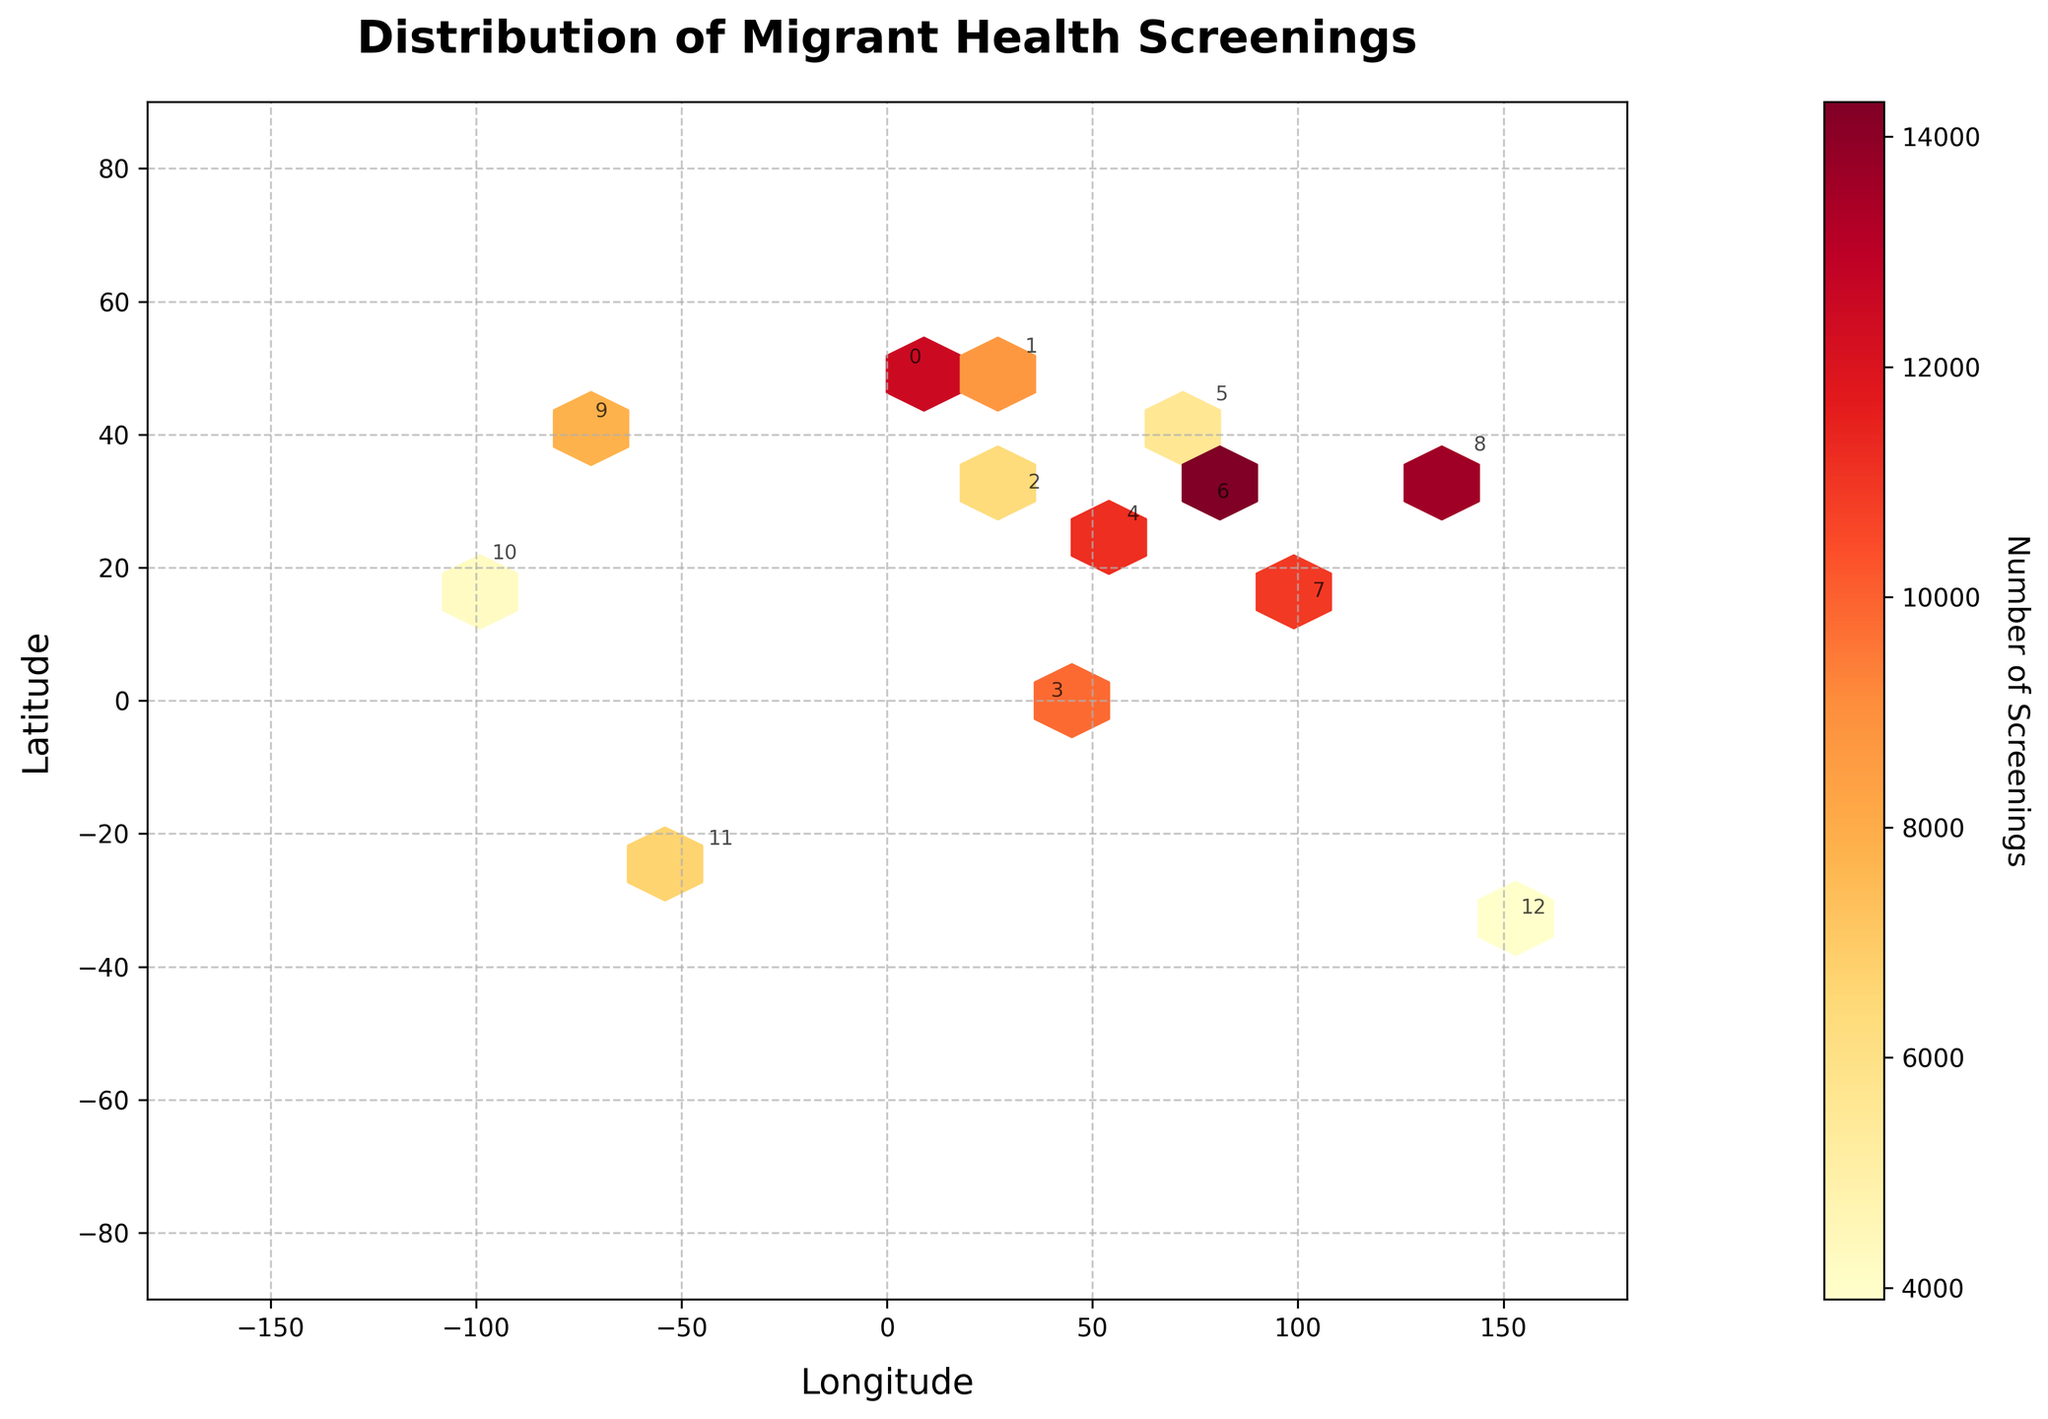What is the title of the hexbin plot? The title of the hexbin plot is usually found at the top of the figure. In this case, it reads "Distribution of Migrant Health Screenings".
Answer: Distribution of Migrant Health Screenings Which global region appears to have the highest number of screenings? The region with the highest number of screenings will have the most saturated color (yellow/red) in the hex bin plot near its geographic coordinates. South Asia has the highest screenings at approximately 14300.
Answer: South Asia What does the color gradient indicate in the hexbin plot? In hexbin plots, the color gradient typically represents the numerical magnitude of the values being plotted. Here, it reflects the number of health screenings, with lighter colors indicating higher numbers.
Answer: Number of Screenings Which two regions are geographically closest to each other? To determine this, you need to look at the relative positions of the annotations on the plot, considering their latitudes and longitudes. Western Europe and Eastern Europe are geographically closest based on their longitude and latitude values.
Answer: Western Europe and Eastern Europe Which region has the lowest number of health screenings, and what is that number? The color representing the least saturated part of the hexbin plot signifies the region with the lowest health screenings. Oceania, around -33.8688 latitude and 151.2093 longitude, has the lowest with 3900 screenings.
Answer: Oceania, 3900 How much more is the number of screenings in South Asia compared to Eastern Europe? To find this, subtract the number of health screenings in Eastern Europe from the number in South Asia: 14300 - 8700.
Answer: 5600 What is the relationship between latitude and the number of screenings for regions in Africa (North and Sub-Saharan Africa)? Looking at the latitudes and the color intensities for North and Sub-Saharan Africa, we can see that Sub-Saharan Africa, with a lower latitude (-1.2921), has a higher number of screenings (9800) than North Africa (30.0444 latitude, 6300 screenings).
Answer: Lower latitude has higher screenings Which region in Asia (including Central, South, Southeast, and East Asia) has the highest screenings? Among these regions, South Asia has the highest screenings as indicated by the brightest color around its geographic coordinates (28.6139 latitude, 77.2090 longitude).
Answer: South Asia How does the distribution of health screenings in the Americas (North, Central, and South America) compare? North America has 7800 screenings, Central America has 4200, and South America has 6700. North America has the highest number, followed by South America, and then Central America. This is observed from the hexbin color saturation.
Answer: North America > South America > Central America What is the average number of screenings across all regions provided in the dataset? Sum all the number of screenings across regions and then divide by the number of regions: (12500 + 8700 + 6300 + 9800 + 11200 + 5600 + 14300 + 10900 + 13600 + 7800 + 4200 + 6700 + 3900) / 13 = 9392.3.
Answer: 9392 